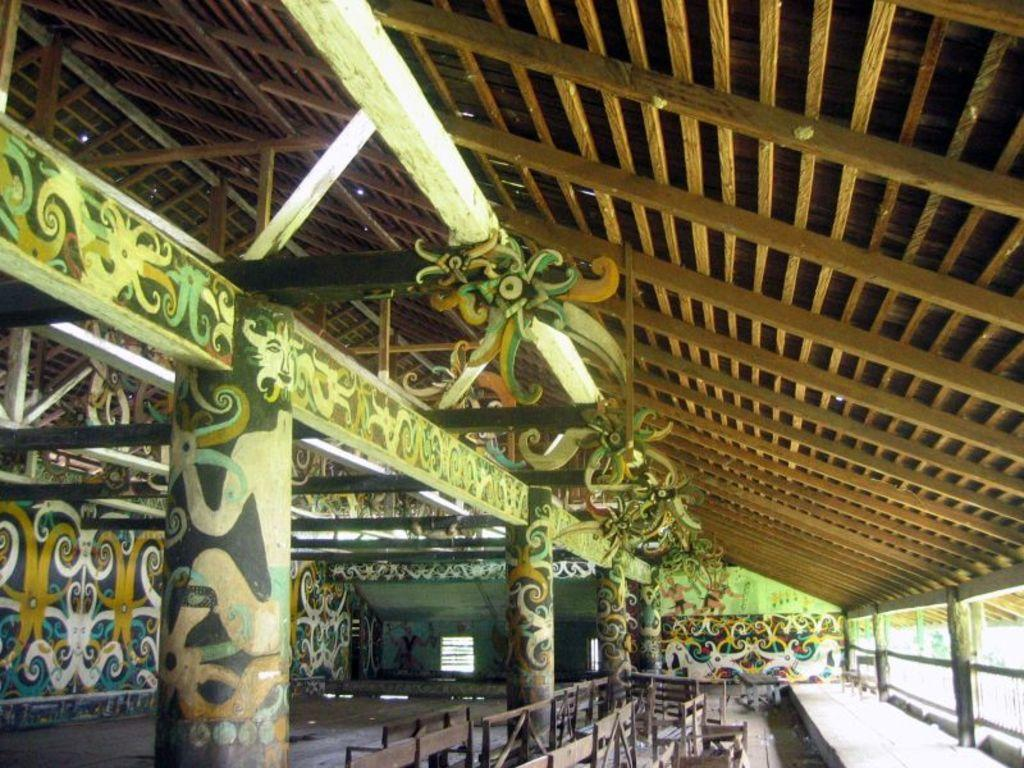What type of location is depicted in the image? The image is an inner view of a building. What can be seen above the depicted area in the image? There is a roof in the image. What separates the indoor space from the outdoor space in the image? There is a fence in the image. How can natural light enter the building in the image? There are windows in the image. What type of artwork is present on the walls and pillars in the image? There are paintings on the walls and pillars in the image. What type of decorations are present in the image? There are decorations in the image. What type of furniture is present in the image for people to sit on? There are benches placed on the surface in the image. What language is being spoken by the tank in the image? There is no tank present in the image, and therefore no language can be attributed to it. 